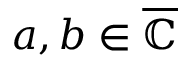<formula> <loc_0><loc_0><loc_500><loc_500>a , b \in { \overline { { \mathbb { C } } } }</formula> 